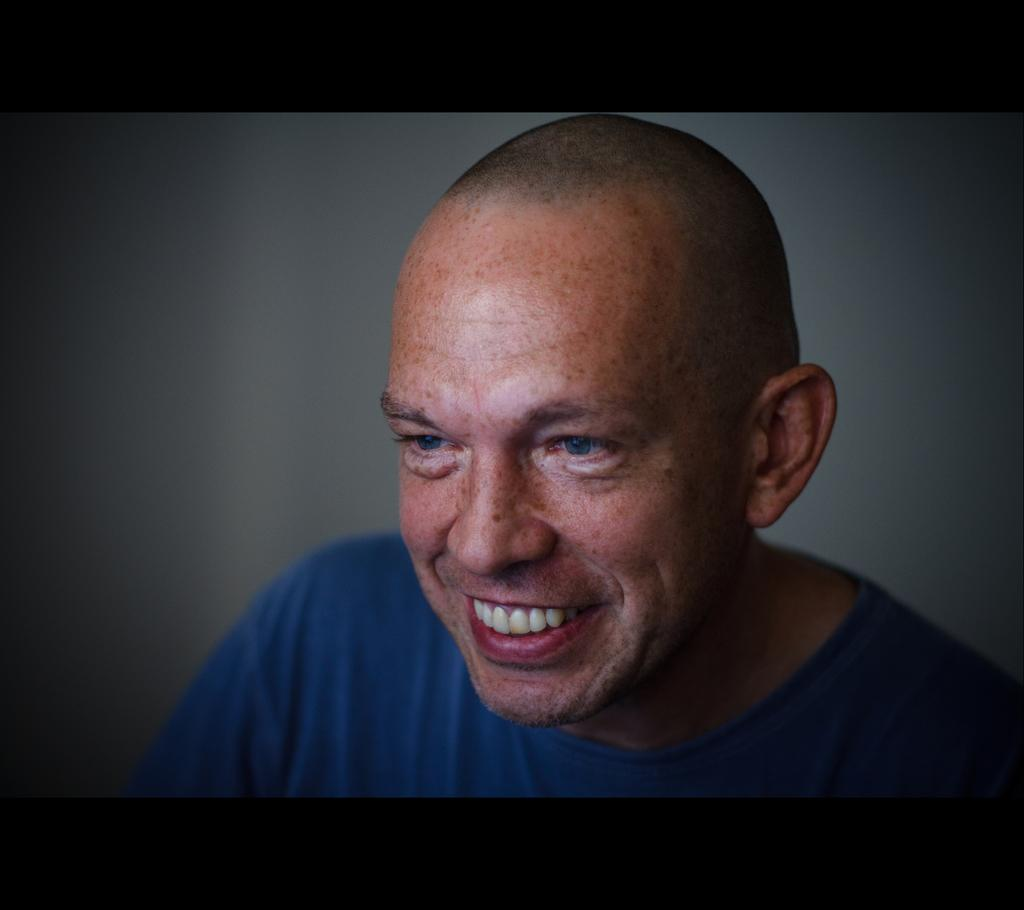Who is present in the image? There is a man in the image. What is the man wearing? The man is wearing a blue T-shirt. What is the man's facial expression? The man is smiling. Can you describe the background of the image? The background of the image is blurred. What type of wool is the man using to knit in the image? There is no wool or knitting activity present in the image. 